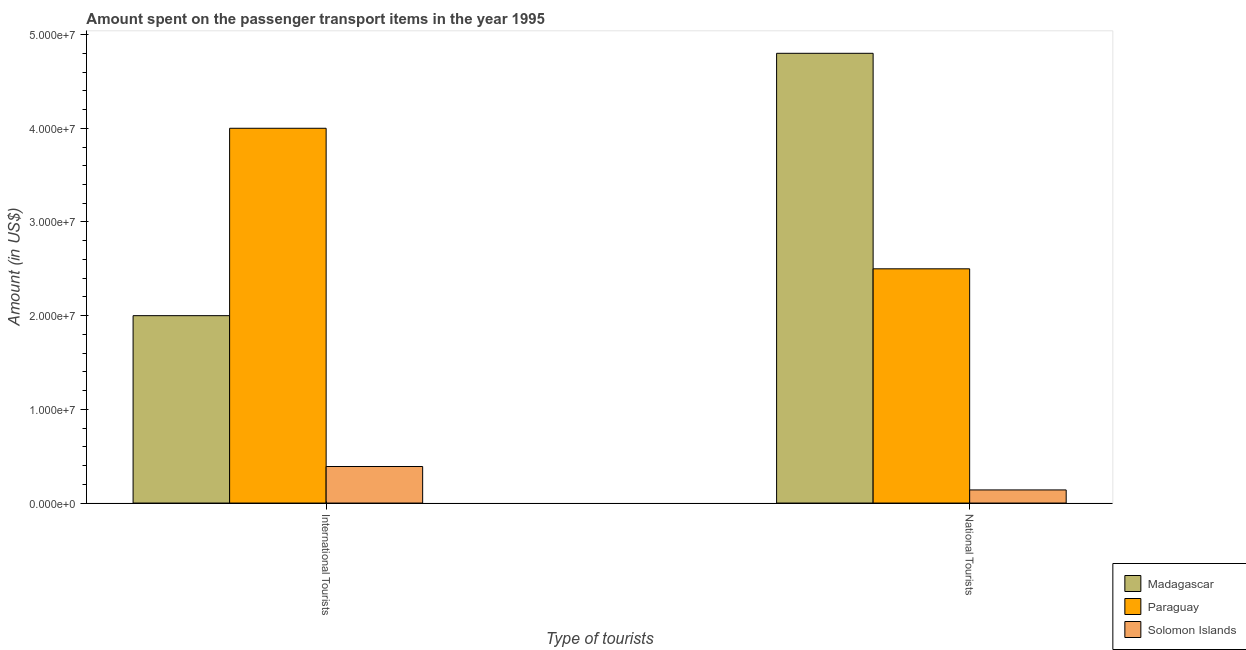How many different coloured bars are there?
Your answer should be compact. 3. How many groups of bars are there?
Provide a short and direct response. 2. How many bars are there on the 1st tick from the left?
Provide a succinct answer. 3. What is the label of the 1st group of bars from the left?
Ensure brevity in your answer.  International Tourists. What is the amount spent on transport items of national tourists in Madagascar?
Provide a short and direct response. 4.80e+07. Across all countries, what is the maximum amount spent on transport items of international tourists?
Provide a short and direct response. 4.00e+07. Across all countries, what is the minimum amount spent on transport items of international tourists?
Your response must be concise. 3.90e+06. In which country was the amount spent on transport items of international tourists maximum?
Keep it short and to the point. Paraguay. In which country was the amount spent on transport items of international tourists minimum?
Provide a succinct answer. Solomon Islands. What is the total amount spent on transport items of national tourists in the graph?
Your answer should be compact. 7.44e+07. What is the difference between the amount spent on transport items of international tourists in Madagascar and that in Paraguay?
Your answer should be compact. -2.00e+07. What is the difference between the amount spent on transport items of national tourists in Solomon Islands and the amount spent on transport items of international tourists in Paraguay?
Give a very brief answer. -3.86e+07. What is the average amount spent on transport items of international tourists per country?
Offer a terse response. 2.13e+07. What is the difference between the amount spent on transport items of national tourists and amount spent on transport items of international tourists in Solomon Islands?
Your answer should be compact. -2.50e+06. What is the ratio of the amount spent on transport items of national tourists in Madagascar to that in Solomon Islands?
Provide a succinct answer. 34.29. What does the 1st bar from the left in National Tourists represents?
Give a very brief answer. Madagascar. What does the 3rd bar from the right in International Tourists represents?
Your answer should be very brief. Madagascar. How many bars are there?
Your answer should be compact. 6. Are all the bars in the graph horizontal?
Provide a succinct answer. No. Are the values on the major ticks of Y-axis written in scientific E-notation?
Offer a very short reply. Yes. Does the graph contain any zero values?
Make the answer very short. No. Where does the legend appear in the graph?
Give a very brief answer. Bottom right. How many legend labels are there?
Offer a very short reply. 3. What is the title of the graph?
Provide a short and direct response. Amount spent on the passenger transport items in the year 1995. What is the label or title of the X-axis?
Offer a very short reply. Type of tourists. What is the Amount (in US$) of Paraguay in International Tourists?
Ensure brevity in your answer.  4.00e+07. What is the Amount (in US$) in Solomon Islands in International Tourists?
Ensure brevity in your answer.  3.90e+06. What is the Amount (in US$) of Madagascar in National Tourists?
Your answer should be very brief. 4.80e+07. What is the Amount (in US$) in Paraguay in National Tourists?
Ensure brevity in your answer.  2.50e+07. What is the Amount (in US$) of Solomon Islands in National Tourists?
Ensure brevity in your answer.  1.40e+06. Across all Type of tourists, what is the maximum Amount (in US$) in Madagascar?
Make the answer very short. 4.80e+07. Across all Type of tourists, what is the maximum Amount (in US$) of Paraguay?
Keep it short and to the point. 4.00e+07. Across all Type of tourists, what is the maximum Amount (in US$) in Solomon Islands?
Provide a short and direct response. 3.90e+06. Across all Type of tourists, what is the minimum Amount (in US$) in Paraguay?
Your response must be concise. 2.50e+07. Across all Type of tourists, what is the minimum Amount (in US$) of Solomon Islands?
Offer a very short reply. 1.40e+06. What is the total Amount (in US$) in Madagascar in the graph?
Ensure brevity in your answer.  6.80e+07. What is the total Amount (in US$) in Paraguay in the graph?
Your answer should be compact. 6.50e+07. What is the total Amount (in US$) in Solomon Islands in the graph?
Your response must be concise. 5.30e+06. What is the difference between the Amount (in US$) of Madagascar in International Tourists and that in National Tourists?
Make the answer very short. -2.80e+07. What is the difference between the Amount (in US$) of Paraguay in International Tourists and that in National Tourists?
Provide a succinct answer. 1.50e+07. What is the difference between the Amount (in US$) in Solomon Islands in International Tourists and that in National Tourists?
Your answer should be very brief. 2.50e+06. What is the difference between the Amount (in US$) in Madagascar in International Tourists and the Amount (in US$) in Paraguay in National Tourists?
Your response must be concise. -5.00e+06. What is the difference between the Amount (in US$) of Madagascar in International Tourists and the Amount (in US$) of Solomon Islands in National Tourists?
Make the answer very short. 1.86e+07. What is the difference between the Amount (in US$) in Paraguay in International Tourists and the Amount (in US$) in Solomon Islands in National Tourists?
Keep it short and to the point. 3.86e+07. What is the average Amount (in US$) in Madagascar per Type of tourists?
Your answer should be very brief. 3.40e+07. What is the average Amount (in US$) in Paraguay per Type of tourists?
Ensure brevity in your answer.  3.25e+07. What is the average Amount (in US$) of Solomon Islands per Type of tourists?
Make the answer very short. 2.65e+06. What is the difference between the Amount (in US$) in Madagascar and Amount (in US$) in Paraguay in International Tourists?
Your response must be concise. -2.00e+07. What is the difference between the Amount (in US$) in Madagascar and Amount (in US$) in Solomon Islands in International Tourists?
Offer a very short reply. 1.61e+07. What is the difference between the Amount (in US$) of Paraguay and Amount (in US$) of Solomon Islands in International Tourists?
Keep it short and to the point. 3.61e+07. What is the difference between the Amount (in US$) in Madagascar and Amount (in US$) in Paraguay in National Tourists?
Your answer should be compact. 2.30e+07. What is the difference between the Amount (in US$) in Madagascar and Amount (in US$) in Solomon Islands in National Tourists?
Make the answer very short. 4.66e+07. What is the difference between the Amount (in US$) of Paraguay and Amount (in US$) of Solomon Islands in National Tourists?
Keep it short and to the point. 2.36e+07. What is the ratio of the Amount (in US$) of Madagascar in International Tourists to that in National Tourists?
Keep it short and to the point. 0.42. What is the ratio of the Amount (in US$) in Solomon Islands in International Tourists to that in National Tourists?
Your response must be concise. 2.79. What is the difference between the highest and the second highest Amount (in US$) in Madagascar?
Make the answer very short. 2.80e+07. What is the difference between the highest and the second highest Amount (in US$) of Paraguay?
Make the answer very short. 1.50e+07. What is the difference between the highest and the second highest Amount (in US$) in Solomon Islands?
Provide a short and direct response. 2.50e+06. What is the difference between the highest and the lowest Amount (in US$) of Madagascar?
Your answer should be compact. 2.80e+07. What is the difference between the highest and the lowest Amount (in US$) in Paraguay?
Your response must be concise. 1.50e+07. What is the difference between the highest and the lowest Amount (in US$) in Solomon Islands?
Provide a short and direct response. 2.50e+06. 